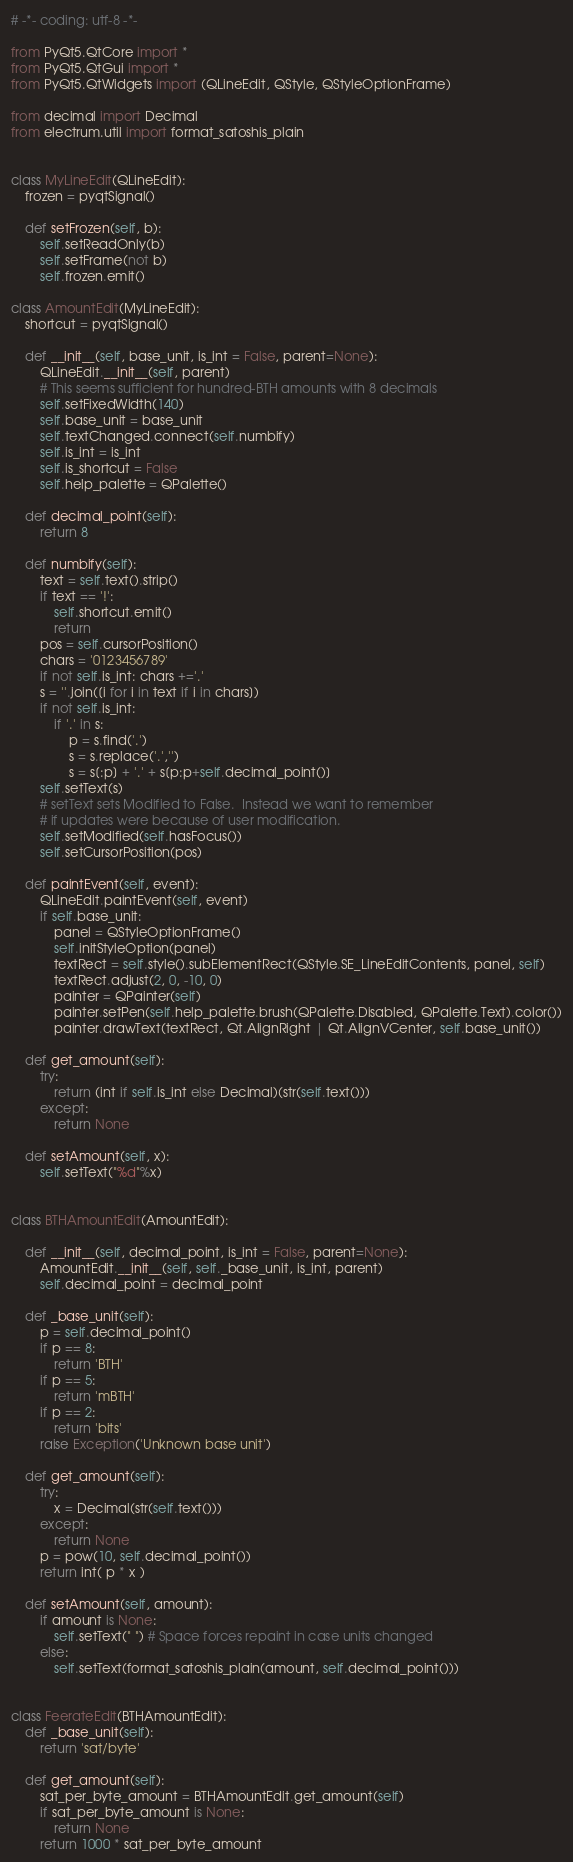<code> <loc_0><loc_0><loc_500><loc_500><_Python_># -*- coding: utf-8 -*-

from PyQt5.QtCore import *
from PyQt5.QtGui import *
from PyQt5.QtWidgets import (QLineEdit, QStyle, QStyleOptionFrame)

from decimal import Decimal
from electrum.util import format_satoshis_plain


class MyLineEdit(QLineEdit):
    frozen = pyqtSignal()

    def setFrozen(self, b):
        self.setReadOnly(b)
        self.setFrame(not b)
        self.frozen.emit()

class AmountEdit(MyLineEdit):
    shortcut = pyqtSignal()

    def __init__(self, base_unit, is_int = False, parent=None):
        QLineEdit.__init__(self, parent)
        # This seems sufficient for hundred-BTH amounts with 8 decimals
        self.setFixedWidth(140)
        self.base_unit = base_unit
        self.textChanged.connect(self.numbify)
        self.is_int = is_int
        self.is_shortcut = False
        self.help_palette = QPalette()

    def decimal_point(self):
        return 8

    def numbify(self):
        text = self.text().strip()
        if text == '!':
            self.shortcut.emit()
            return
        pos = self.cursorPosition()
        chars = '0123456789'
        if not self.is_int: chars +='.'
        s = ''.join([i for i in text if i in chars])
        if not self.is_int:
            if '.' in s:
                p = s.find('.')
                s = s.replace('.','')
                s = s[:p] + '.' + s[p:p+self.decimal_point()]
        self.setText(s)
        # setText sets Modified to False.  Instead we want to remember
        # if updates were because of user modification.
        self.setModified(self.hasFocus())
        self.setCursorPosition(pos)

    def paintEvent(self, event):
        QLineEdit.paintEvent(self, event)
        if self.base_unit:
            panel = QStyleOptionFrame()
            self.initStyleOption(panel)
            textRect = self.style().subElementRect(QStyle.SE_LineEditContents, panel, self)
            textRect.adjust(2, 0, -10, 0)
            painter = QPainter(self)
            painter.setPen(self.help_palette.brush(QPalette.Disabled, QPalette.Text).color())
            painter.drawText(textRect, Qt.AlignRight | Qt.AlignVCenter, self.base_unit())

    def get_amount(self):
        try:
            return (int if self.is_int else Decimal)(str(self.text()))
        except:
            return None

    def setAmount(self, x):
        self.setText("%d"%x)


class BTHAmountEdit(AmountEdit):

    def __init__(self, decimal_point, is_int = False, parent=None):
        AmountEdit.__init__(self, self._base_unit, is_int, parent)
        self.decimal_point = decimal_point

    def _base_unit(self):
        p = self.decimal_point()
        if p == 8:
            return 'BTH'
        if p == 5:
            return 'mBTH'
        if p == 2:
            return 'bits'
        raise Exception('Unknown base unit')

    def get_amount(self):
        try:
            x = Decimal(str(self.text()))
        except:
            return None
        p = pow(10, self.decimal_point())
        return int( p * x )

    def setAmount(self, amount):
        if amount is None:
            self.setText(" ") # Space forces repaint in case units changed
        else:
            self.setText(format_satoshis_plain(amount, self.decimal_point()))


class FeerateEdit(BTHAmountEdit):
    def _base_unit(self):
        return 'sat/byte'

    def get_amount(self):
        sat_per_byte_amount = BTHAmountEdit.get_amount(self)
        if sat_per_byte_amount is None:
            return None
        return 1000 * sat_per_byte_amount
</code> 